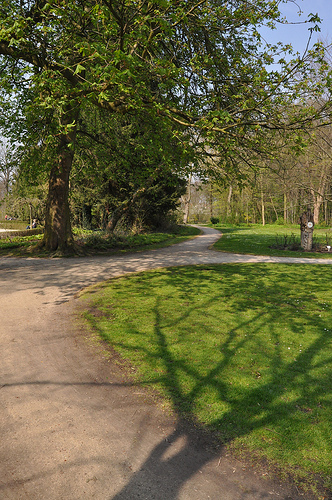<image>
Is there a tree above the path? No. The tree is not positioned above the path. The vertical arrangement shows a different relationship. 